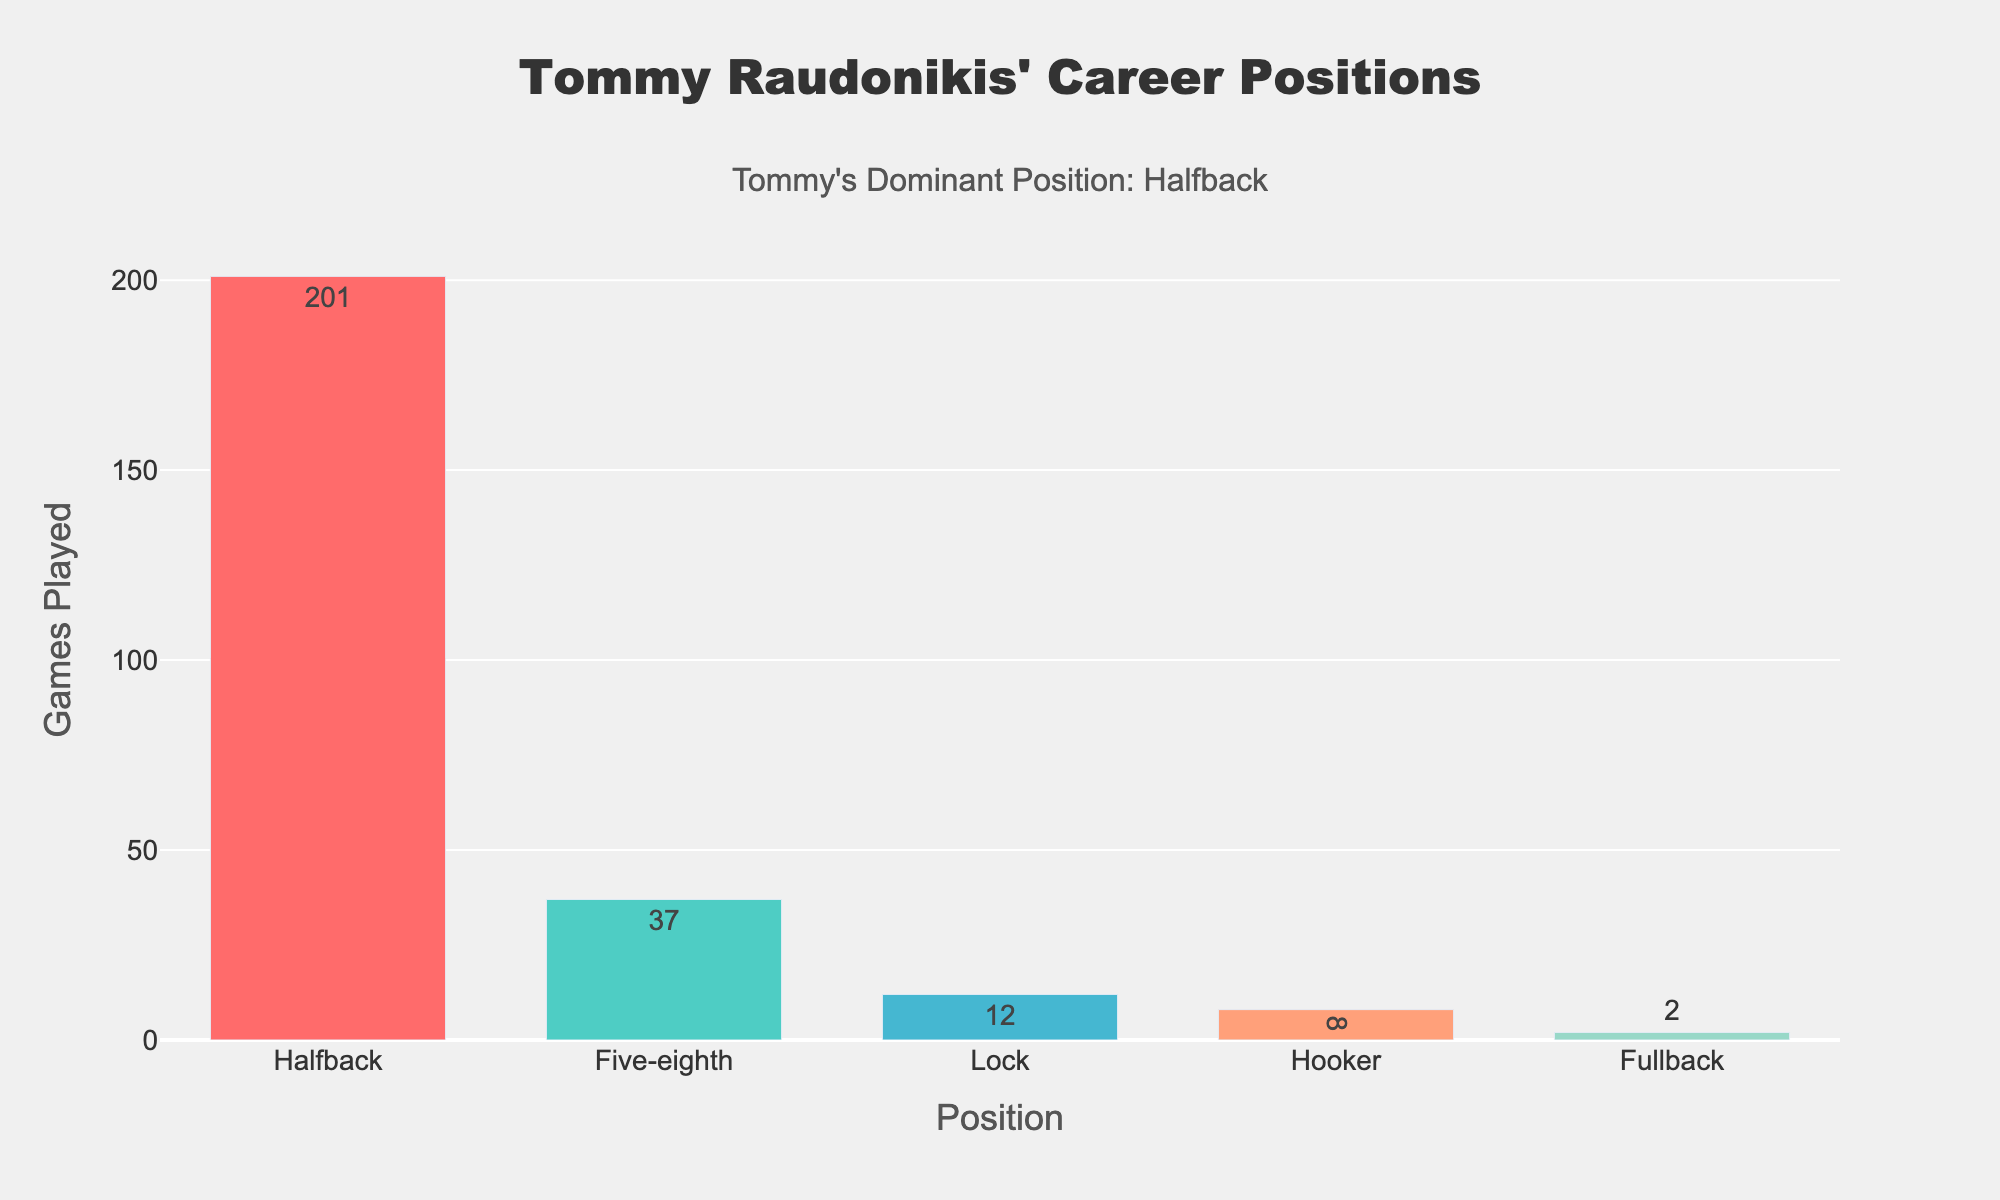What's the total number of games Tommy played at Five-eighth and Lock? To find the total number of games played at Five-eighth and Lock, add the games played in each position: 37 (Five-eighth) + 12 (Lock) = 49.
Answer: 49 Which position did Tommy play in the fewest number of games? By examining the bar heights, Fullback has the smallest bar, representing the fewest games played, which is 2 games.
Answer: Fullback How many more games did Tommy play at Halfback than at Hooker? Subtract the number of games played at Hooker from the number of games played at Halfback: 201 (Halfback) - 8 (Hooker) = 193.
Answer: 193 What's the average number of games played across all positions? To find the average, sum the games played in all positions and divide by the number of positions: (201 + 37 + 12 + 8 + 2) / 5 = 260 / 5 = 52.
Answer: 52 Which position is represented by the blue color in the plot? The position represented by the blue color is Hooker. This can be determined by looking at the color of the bars.
Answer: Hooker By how many games does the total number of games played at Halfback exceed the combined total of games played at Fullback and Lock? Combine the games played at Fullback and Lock and subtract from the games played at Halfback: 201 (Halfback) - (2 + 12) = 201 - 14 = 187.
Answer: 187 How many times more games did Tommy play at Halfback compared to Fullback? Divide the number of games played at Halfback by the number of games played at Fullback: 201 / 2 = 100.5.
Answer: 100.5 What's the second most frequently played position in Tommy’s career? By looking at the heights of the bars, the second tallest bar represents Five-eighth with 37 games played.
Answer: Five-eighth 